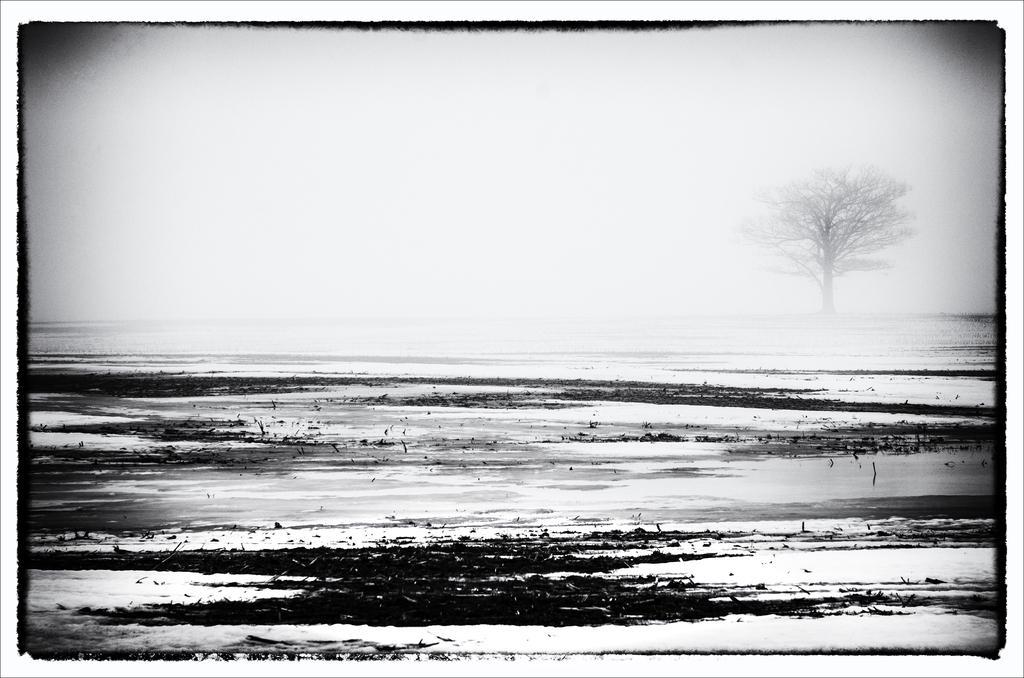What is the color scheme of the image? The image is black and white. What can be seen in the center of the image? There is water in the center of the image. What is visible in the background of the image? There is a tree in the background of the image. What type of letter is being delivered by the sail in the image? There is no sail or letter present in the image; it is a black and white image featuring water and a tree in the background. 